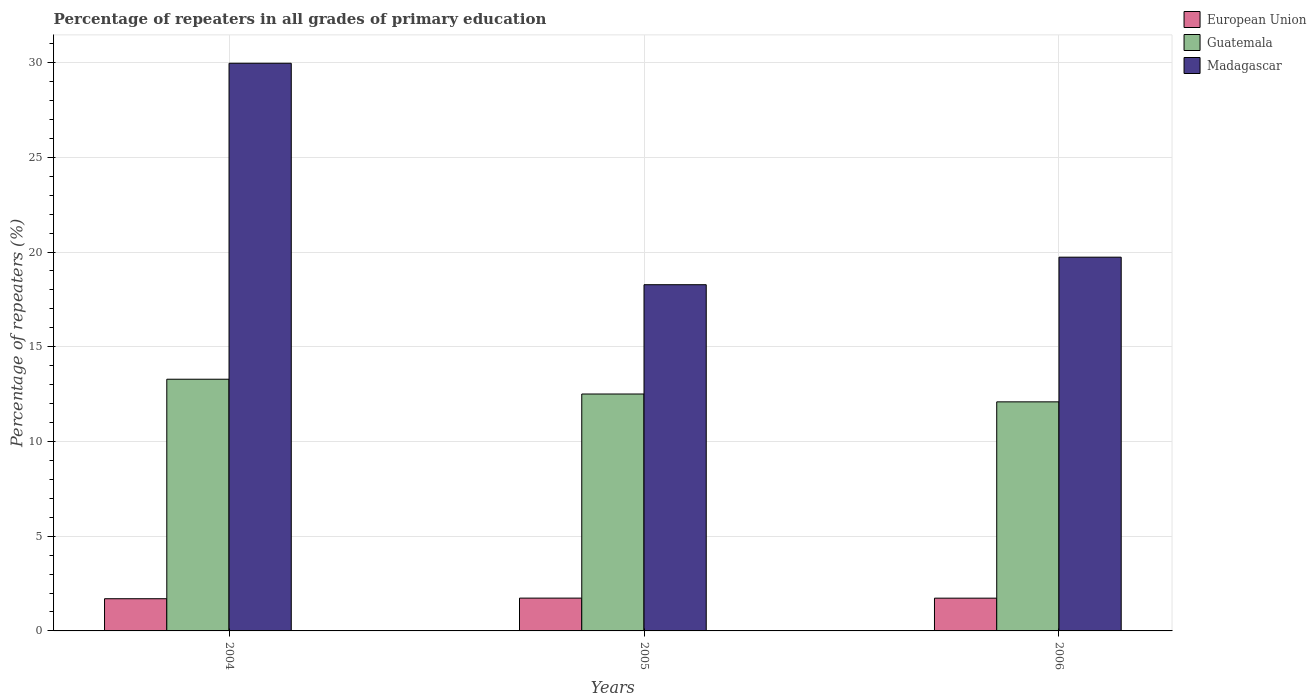How many different coloured bars are there?
Your answer should be very brief. 3. How many groups of bars are there?
Your answer should be compact. 3. How many bars are there on the 1st tick from the left?
Ensure brevity in your answer.  3. How many bars are there on the 1st tick from the right?
Give a very brief answer. 3. What is the label of the 2nd group of bars from the left?
Offer a very short reply. 2005. What is the percentage of repeaters in European Union in 2005?
Offer a very short reply. 1.73. Across all years, what is the maximum percentage of repeaters in European Union?
Provide a short and direct response. 1.73. Across all years, what is the minimum percentage of repeaters in Madagascar?
Offer a very short reply. 18.27. In which year was the percentage of repeaters in European Union maximum?
Your answer should be very brief. 2005. In which year was the percentage of repeaters in European Union minimum?
Make the answer very short. 2004. What is the total percentage of repeaters in Guatemala in the graph?
Your response must be concise. 37.88. What is the difference between the percentage of repeaters in European Union in 2004 and that in 2005?
Offer a very short reply. -0.03. What is the difference between the percentage of repeaters in Guatemala in 2005 and the percentage of repeaters in European Union in 2006?
Provide a short and direct response. 10.78. What is the average percentage of repeaters in Guatemala per year?
Make the answer very short. 12.63. In the year 2005, what is the difference between the percentage of repeaters in Guatemala and percentage of repeaters in European Union?
Your answer should be very brief. 10.77. What is the ratio of the percentage of repeaters in European Union in 2004 to that in 2006?
Make the answer very short. 0.98. Is the percentage of repeaters in Madagascar in 2005 less than that in 2006?
Give a very brief answer. Yes. What is the difference between the highest and the second highest percentage of repeaters in European Union?
Make the answer very short. 0. What is the difference between the highest and the lowest percentage of repeaters in Madagascar?
Your answer should be very brief. 11.69. Is the sum of the percentage of repeaters in European Union in 2004 and 2006 greater than the maximum percentage of repeaters in Madagascar across all years?
Offer a very short reply. No. What does the 3rd bar from the left in 2004 represents?
Give a very brief answer. Madagascar. What does the 2nd bar from the right in 2005 represents?
Give a very brief answer. Guatemala. Is it the case that in every year, the sum of the percentage of repeaters in European Union and percentage of repeaters in Guatemala is greater than the percentage of repeaters in Madagascar?
Provide a succinct answer. No. How many bars are there?
Your answer should be compact. 9. Are all the bars in the graph horizontal?
Give a very brief answer. No. How many years are there in the graph?
Provide a succinct answer. 3. Are the values on the major ticks of Y-axis written in scientific E-notation?
Give a very brief answer. No. Where does the legend appear in the graph?
Give a very brief answer. Top right. How are the legend labels stacked?
Your answer should be compact. Vertical. What is the title of the graph?
Your response must be concise. Percentage of repeaters in all grades of primary education. Does "Pakistan" appear as one of the legend labels in the graph?
Provide a succinct answer. No. What is the label or title of the X-axis?
Your response must be concise. Years. What is the label or title of the Y-axis?
Ensure brevity in your answer.  Percentage of repeaters (%). What is the Percentage of repeaters (%) in European Union in 2004?
Offer a terse response. 1.7. What is the Percentage of repeaters (%) in Guatemala in 2004?
Your answer should be compact. 13.29. What is the Percentage of repeaters (%) of Madagascar in 2004?
Provide a short and direct response. 29.96. What is the Percentage of repeaters (%) in European Union in 2005?
Offer a terse response. 1.73. What is the Percentage of repeaters (%) in Guatemala in 2005?
Give a very brief answer. 12.51. What is the Percentage of repeaters (%) of Madagascar in 2005?
Make the answer very short. 18.27. What is the Percentage of repeaters (%) of European Union in 2006?
Keep it short and to the point. 1.73. What is the Percentage of repeaters (%) in Guatemala in 2006?
Ensure brevity in your answer.  12.09. What is the Percentage of repeaters (%) of Madagascar in 2006?
Offer a terse response. 19.73. Across all years, what is the maximum Percentage of repeaters (%) in European Union?
Give a very brief answer. 1.73. Across all years, what is the maximum Percentage of repeaters (%) in Guatemala?
Provide a succinct answer. 13.29. Across all years, what is the maximum Percentage of repeaters (%) of Madagascar?
Provide a short and direct response. 29.96. Across all years, what is the minimum Percentage of repeaters (%) in European Union?
Keep it short and to the point. 1.7. Across all years, what is the minimum Percentage of repeaters (%) in Guatemala?
Keep it short and to the point. 12.09. Across all years, what is the minimum Percentage of repeaters (%) of Madagascar?
Offer a very short reply. 18.27. What is the total Percentage of repeaters (%) in European Union in the graph?
Your response must be concise. 5.16. What is the total Percentage of repeaters (%) of Guatemala in the graph?
Offer a very short reply. 37.88. What is the total Percentage of repeaters (%) of Madagascar in the graph?
Provide a short and direct response. 67.97. What is the difference between the Percentage of repeaters (%) of European Union in 2004 and that in 2005?
Make the answer very short. -0.03. What is the difference between the Percentage of repeaters (%) of Guatemala in 2004 and that in 2005?
Provide a short and direct response. 0.78. What is the difference between the Percentage of repeaters (%) in Madagascar in 2004 and that in 2005?
Give a very brief answer. 11.69. What is the difference between the Percentage of repeaters (%) in European Union in 2004 and that in 2006?
Provide a succinct answer. -0.03. What is the difference between the Percentage of repeaters (%) of Guatemala in 2004 and that in 2006?
Make the answer very short. 1.19. What is the difference between the Percentage of repeaters (%) of Madagascar in 2004 and that in 2006?
Give a very brief answer. 10.24. What is the difference between the Percentage of repeaters (%) of European Union in 2005 and that in 2006?
Offer a very short reply. 0. What is the difference between the Percentage of repeaters (%) of Guatemala in 2005 and that in 2006?
Offer a very short reply. 0.41. What is the difference between the Percentage of repeaters (%) of Madagascar in 2005 and that in 2006?
Provide a succinct answer. -1.45. What is the difference between the Percentage of repeaters (%) in European Union in 2004 and the Percentage of repeaters (%) in Guatemala in 2005?
Your answer should be compact. -10.81. What is the difference between the Percentage of repeaters (%) in European Union in 2004 and the Percentage of repeaters (%) in Madagascar in 2005?
Keep it short and to the point. -16.58. What is the difference between the Percentage of repeaters (%) in Guatemala in 2004 and the Percentage of repeaters (%) in Madagascar in 2005?
Make the answer very short. -4.99. What is the difference between the Percentage of repeaters (%) of European Union in 2004 and the Percentage of repeaters (%) of Guatemala in 2006?
Your response must be concise. -10.39. What is the difference between the Percentage of repeaters (%) in European Union in 2004 and the Percentage of repeaters (%) in Madagascar in 2006?
Your answer should be compact. -18.03. What is the difference between the Percentage of repeaters (%) in Guatemala in 2004 and the Percentage of repeaters (%) in Madagascar in 2006?
Provide a succinct answer. -6.44. What is the difference between the Percentage of repeaters (%) of European Union in 2005 and the Percentage of repeaters (%) of Guatemala in 2006?
Provide a short and direct response. -10.36. What is the difference between the Percentage of repeaters (%) of European Union in 2005 and the Percentage of repeaters (%) of Madagascar in 2006?
Keep it short and to the point. -18. What is the difference between the Percentage of repeaters (%) of Guatemala in 2005 and the Percentage of repeaters (%) of Madagascar in 2006?
Provide a succinct answer. -7.22. What is the average Percentage of repeaters (%) of European Union per year?
Offer a terse response. 1.72. What is the average Percentage of repeaters (%) in Guatemala per year?
Give a very brief answer. 12.63. What is the average Percentage of repeaters (%) of Madagascar per year?
Offer a terse response. 22.66. In the year 2004, what is the difference between the Percentage of repeaters (%) in European Union and Percentage of repeaters (%) in Guatemala?
Provide a succinct answer. -11.59. In the year 2004, what is the difference between the Percentage of repeaters (%) in European Union and Percentage of repeaters (%) in Madagascar?
Keep it short and to the point. -28.26. In the year 2004, what is the difference between the Percentage of repeaters (%) in Guatemala and Percentage of repeaters (%) in Madagascar?
Provide a succinct answer. -16.68. In the year 2005, what is the difference between the Percentage of repeaters (%) in European Union and Percentage of repeaters (%) in Guatemala?
Provide a short and direct response. -10.77. In the year 2005, what is the difference between the Percentage of repeaters (%) of European Union and Percentage of repeaters (%) of Madagascar?
Your response must be concise. -16.54. In the year 2005, what is the difference between the Percentage of repeaters (%) in Guatemala and Percentage of repeaters (%) in Madagascar?
Your response must be concise. -5.77. In the year 2006, what is the difference between the Percentage of repeaters (%) of European Union and Percentage of repeaters (%) of Guatemala?
Keep it short and to the point. -10.36. In the year 2006, what is the difference between the Percentage of repeaters (%) in European Union and Percentage of repeaters (%) in Madagascar?
Your answer should be compact. -18. In the year 2006, what is the difference between the Percentage of repeaters (%) in Guatemala and Percentage of repeaters (%) in Madagascar?
Make the answer very short. -7.64. What is the ratio of the Percentage of repeaters (%) of European Union in 2004 to that in 2005?
Keep it short and to the point. 0.98. What is the ratio of the Percentage of repeaters (%) in Guatemala in 2004 to that in 2005?
Make the answer very short. 1.06. What is the ratio of the Percentage of repeaters (%) of Madagascar in 2004 to that in 2005?
Offer a very short reply. 1.64. What is the ratio of the Percentage of repeaters (%) in European Union in 2004 to that in 2006?
Give a very brief answer. 0.98. What is the ratio of the Percentage of repeaters (%) of Guatemala in 2004 to that in 2006?
Offer a very short reply. 1.1. What is the ratio of the Percentage of repeaters (%) in Madagascar in 2004 to that in 2006?
Your response must be concise. 1.52. What is the ratio of the Percentage of repeaters (%) in European Union in 2005 to that in 2006?
Ensure brevity in your answer.  1. What is the ratio of the Percentage of repeaters (%) of Guatemala in 2005 to that in 2006?
Your answer should be very brief. 1.03. What is the ratio of the Percentage of repeaters (%) in Madagascar in 2005 to that in 2006?
Keep it short and to the point. 0.93. What is the difference between the highest and the second highest Percentage of repeaters (%) in European Union?
Make the answer very short. 0. What is the difference between the highest and the second highest Percentage of repeaters (%) in Guatemala?
Offer a very short reply. 0.78. What is the difference between the highest and the second highest Percentage of repeaters (%) in Madagascar?
Offer a very short reply. 10.24. What is the difference between the highest and the lowest Percentage of repeaters (%) in European Union?
Provide a succinct answer. 0.03. What is the difference between the highest and the lowest Percentage of repeaters (%) of Guatemala?
Make the answer very short. 1.19. What is the difference between the highest and the lowest Percentage of repeaters (%) of Madagascar?
Give a very brief answer. 11.69. 